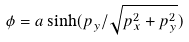Convert formula to latex. <formula><loc_0><loc_0><loc_500><loc_500>\phi = a \sinh ( p _ { y } / \sqrt { p _ { x } ^ { 2 } + p _ { y } ^ { 2 } } )</formula> 